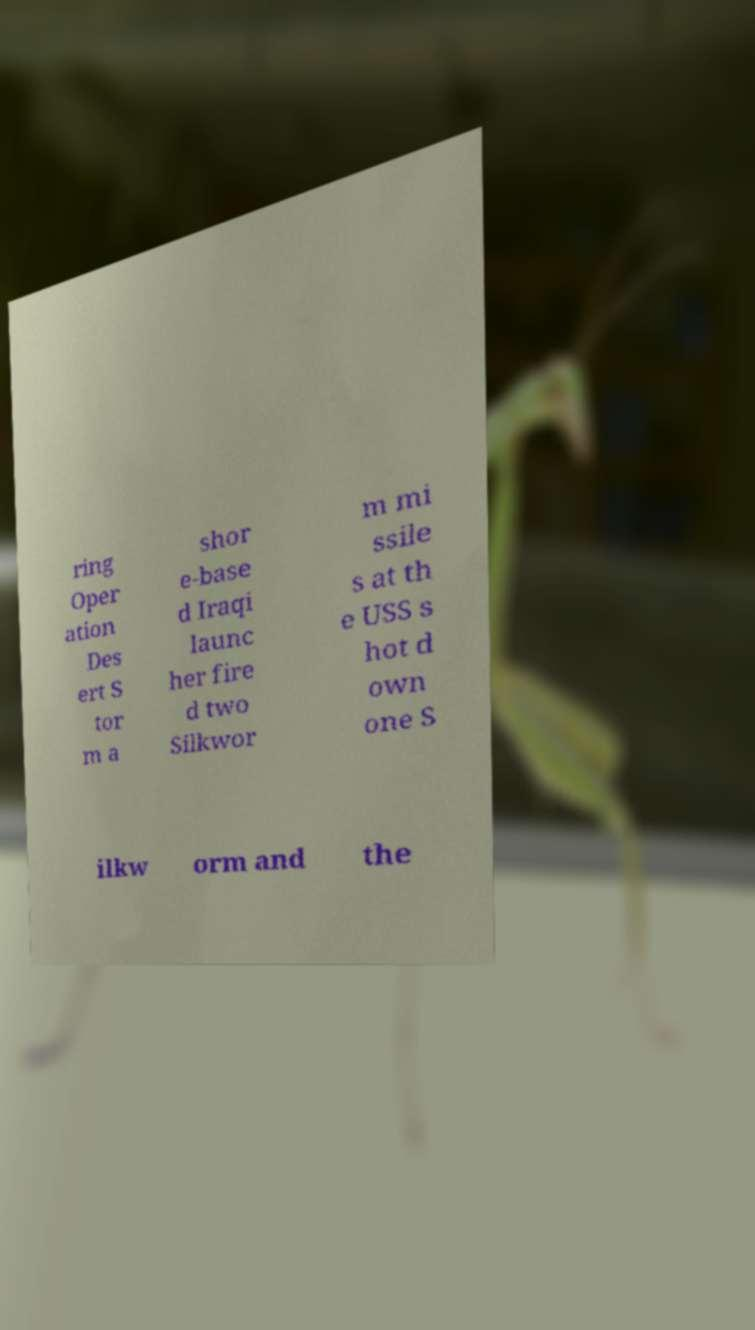Please identify and transcribe the text found in this image. ring Oper ation Des ert S tor m a shor e-base d Iraqi launc her fire d two Silkwor m mi ssile s at th e USS s hot d own one S ilkw orm and the 